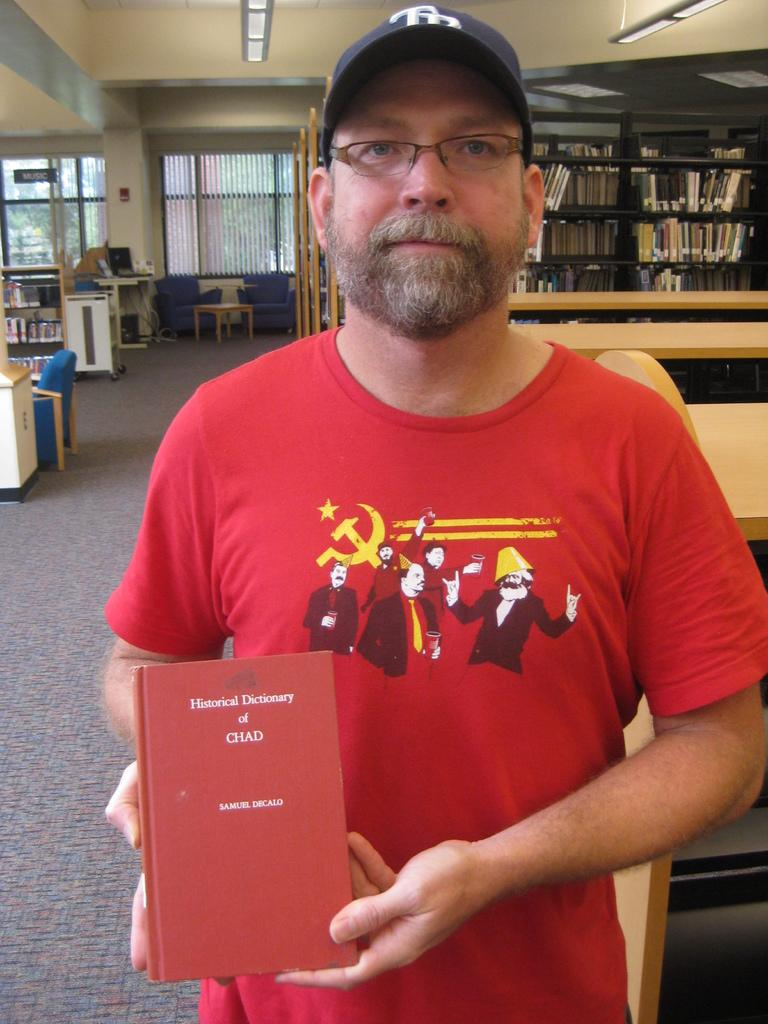<image>
Describe the image concisely. A man in a red shirt and a black baseball cap is holding a book titled Historical Dictionary of Chad by Samuel Decalo 